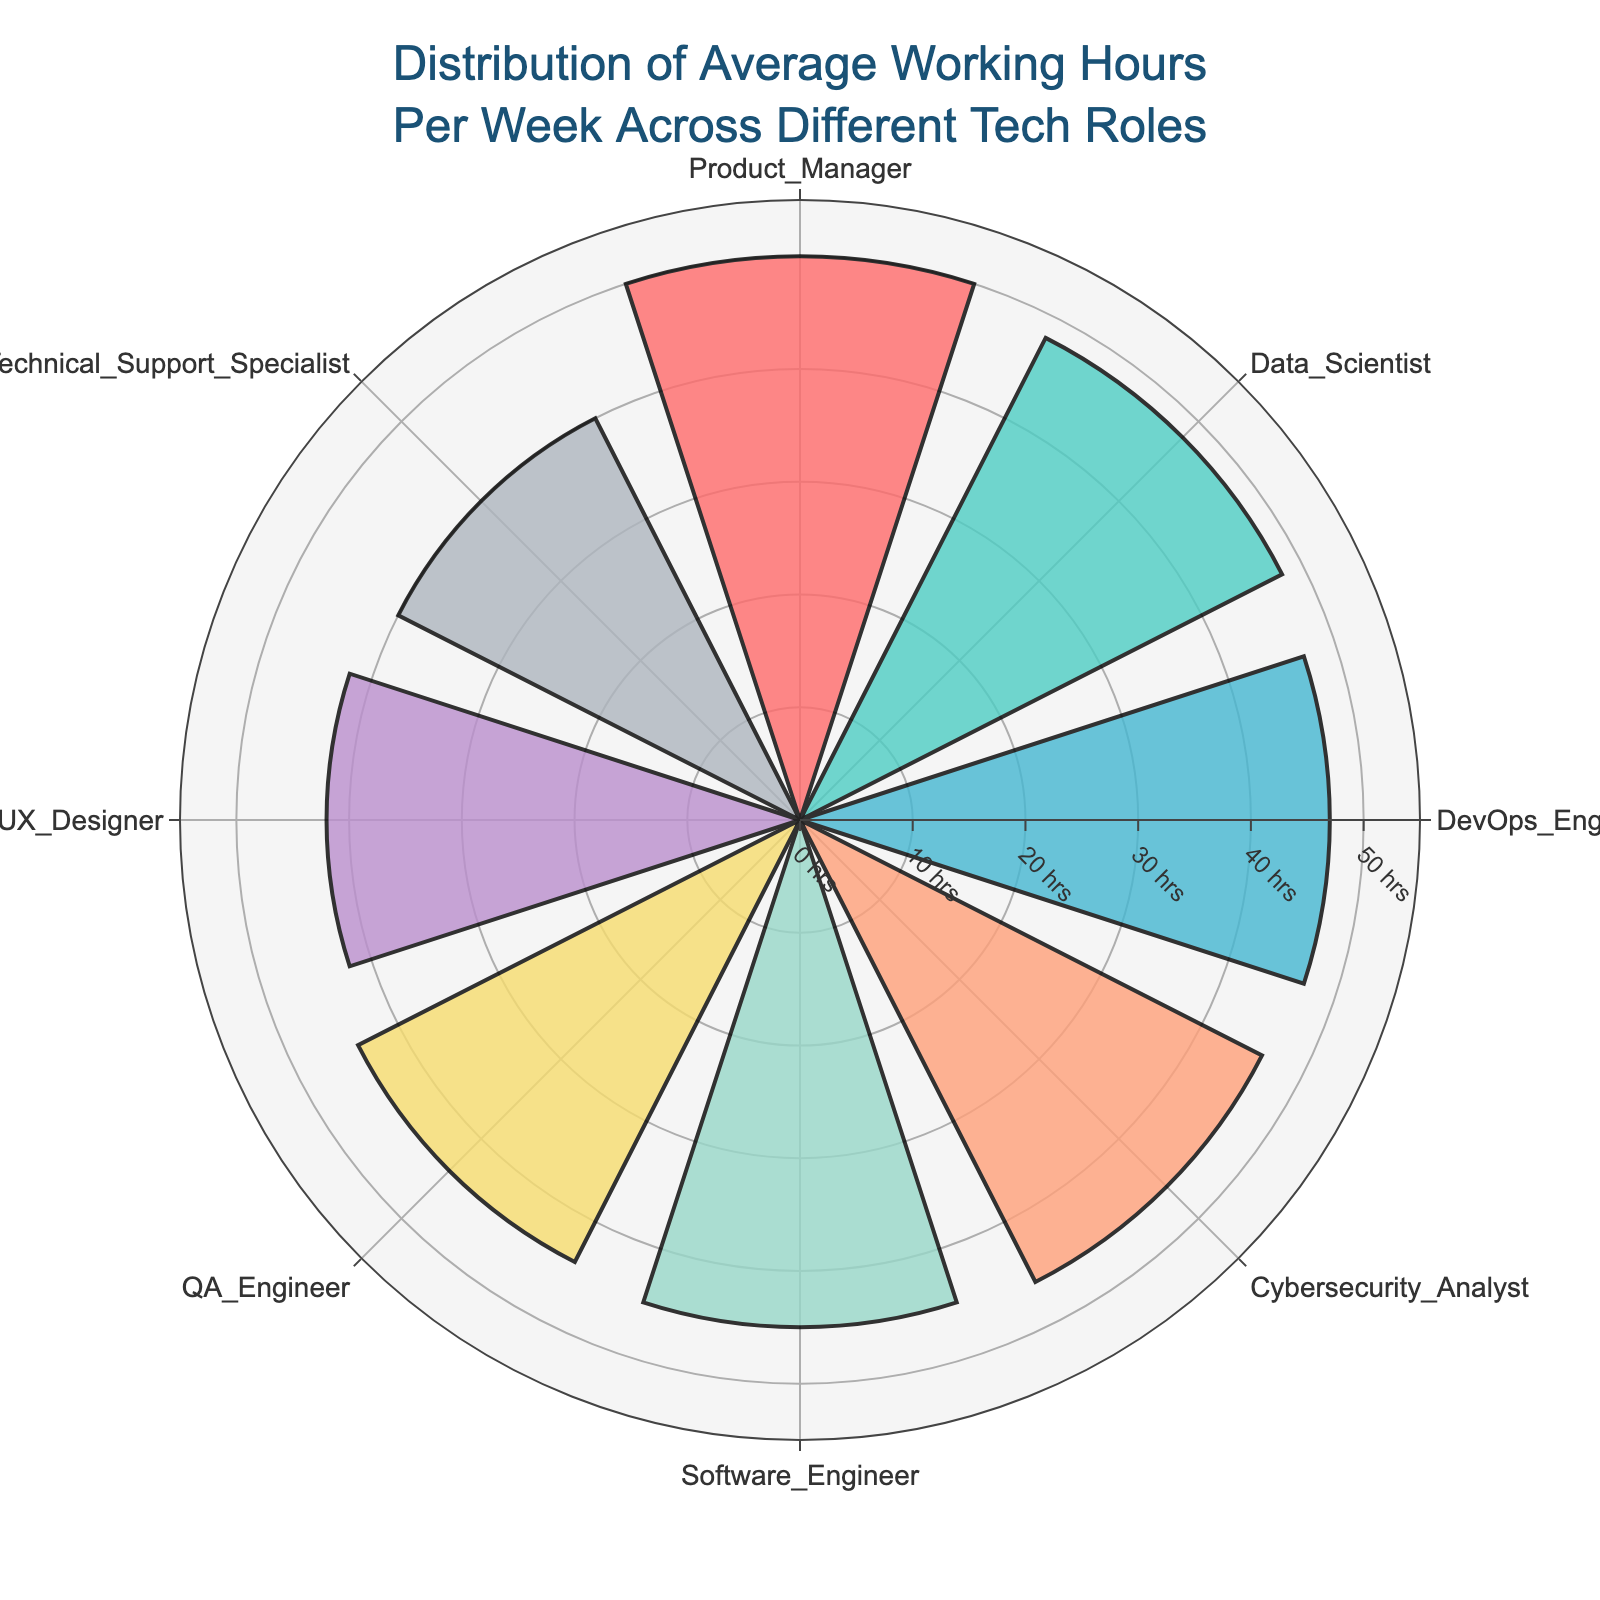What's the title of the chart? The title is prominently displayed at the top of the chart. It reads "Distribution of Average Working Hours Per Week Across Different Tech Roles".
Answer: Distribution of Average Working Hours Per Week Across Different Tech Roles Which role has the highest average working hours? By looking at the length of the bars and their labels, the role with the longest bar is the Product Manager.
Answer: Product Manager How many roles average over 45 hours per week? Identify the bars with radial values greater than 45. There are four of them: Product Manager, Data Scientist, DevOps Engineer, and Cybersecurity Analyst.
Answer: 4 What is the average working hours difference between a UX Designer and a Product Manager? Subtract the average working hours of the UX Designer (42) from those of the Product Manager (50). The difference is 50 - 42.
Answer: 8 hours Rank the roles from highest to lowest average working hours. List the roles in descending order based on the length of their bars: Product Manager, Data Scientist, DevOps Engineer, Cybersecurity Analyst, Software Engineer, QA Engineer, UX Designer, Technical Support Specialist.
Answer: Product Manager, Data Scientist, DevOps Engineer, Cybersecurity Analyst, Software Engineer, QA Engineer, UX Designer, Technical Support Specialist Which role has the lowest average working hours? The role with the shortest bar is the Technical Support Specialist.
Answer: Technical Support Specialist How many roles have average working hours below 45? Identify the bars with radial values less than 45. There are four such roles: UX Designer, QA Engineer, and Technical Support Specialist.
Answer: 3 What are the colors used for the roles with the highest and lowest working hours? The color of the bar for the Product Manager is examined as well as for the Technical Support Specialist. The colors are '#45B7D1' for Product Manager and '#AEB6BF' for Technical Support Specialist.
Answer: Example: light blue, grey (Note: Exact names/descriptions) What would be the average working hours for all roles combined? Sum the average working hours for all roles and divide by the number of roles: (45 + 48 + 50 + 42 + 44 + 47 + 46 + 40)/8 = 45.25 hours.
Answer: 45.25 hours How does the average working hours of a Data Scientist compare to a DevOps Engineer? Observing the radial values, the Data Scientist works 48 hours per week, while the DevOps Engineer works 47. Therefore, the Data Scientist works 1 hour more.
Answer: Data Scientist works 1 hour more 